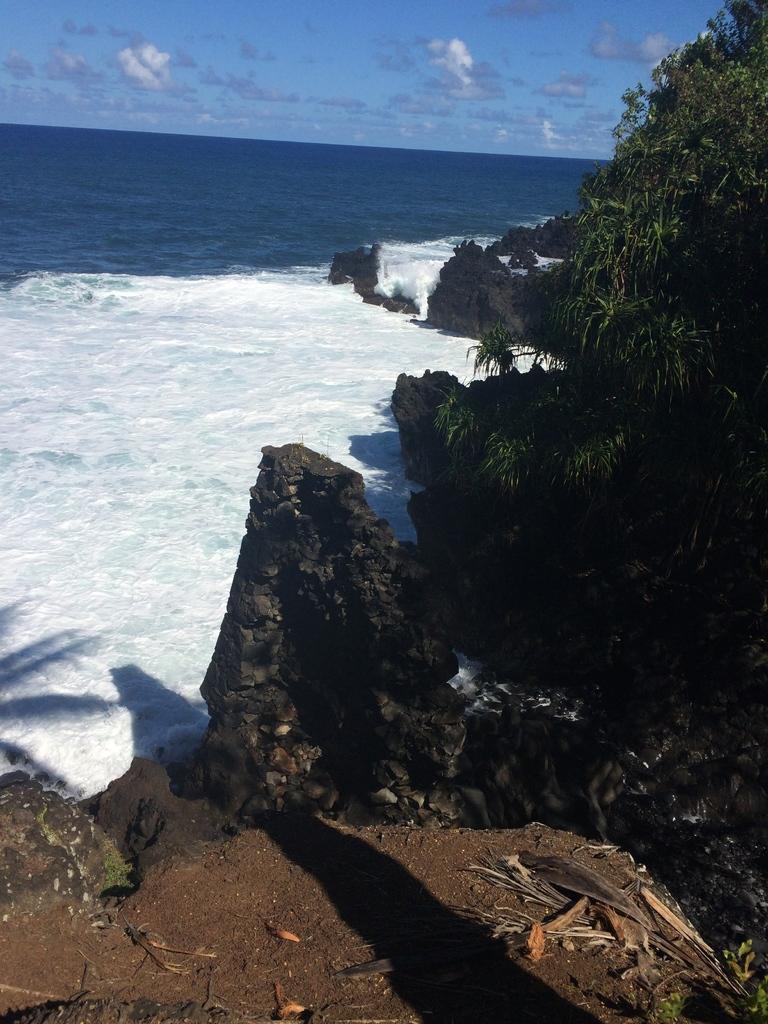Describe this image in one or two sentences. In this image there is the water. To the right there are rocks. There are plants on the rocks. At the top there is the sky. 